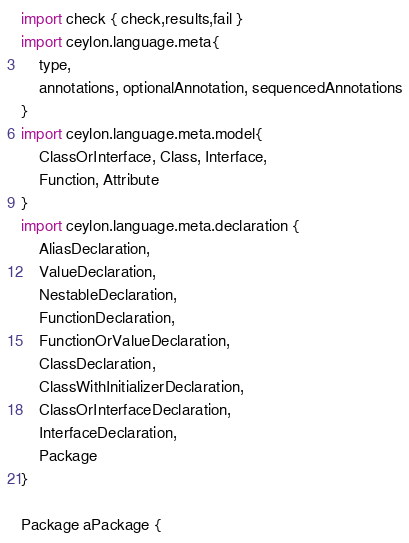Convert code to text. <code><loc_0><loc_0><loc_500><loc_500><_Ceylon_>import check { check,results,fail }
import ceylon.language.meta{
    type, 
    annotations, optionalAnnotation, sequencedAnnotations
}
import ceylon.language.meta.model{
    ClassOrInterface, Class, Interface,
    Function, Attribute
}
import ceylon.language.meta.declaration {
    AliasDeclaration,
    ValueDeclaration,
    NestableDeclaration,
    FunctionDeclaration,
    FunctionOrValueDeclaration,
    ClassDeclaration,
    ClassWithInitializerDeclaration,
    ClassOrInterfaceDeclaration,
    InterfaceDeclaration,
    Package
}

Package aPackage {</code> 